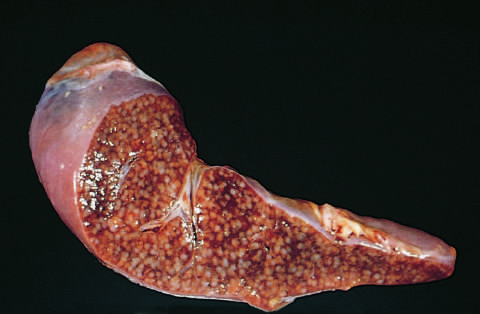does the cut surface show numerous gray-white granulomas?
Answer the question using a single word or phrase. Yes 